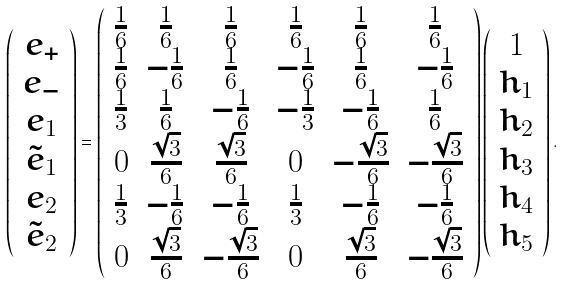Convert formula to latex. <formula><loc_0><loc_0><loc_500><loc_500>\left ( \begin{array} { c } e _ { + } \\ e _ { - } \\ e _ { 1 } \\ \tilde { e } _ { 1 } \\ e _ { 2 } \\ \tilde { e } _ { 2 } \\ \end{array} \right ) = \left ( \begin{array} { c c c c c c } \frac { 1 } { 6 } & \frac { 1 } { 6 } & \frac { 1 } { 6 } & \frac { 1 } { 6 } & \frac { 1 } { 6 } & \frac { 1 } { 6 } \\ \frac { 1 } { 6 } & - \frac { 1 } { 6 } & \frac { 1 } { 6 } & - \frac { 1 } { 6 } & \frac { 1 } { 6 } & - \frac { 1 } { 6 } \\ \frac { 1 } { 3 } & \frac { 1 } { 6 } & - \frac { 1 } { 6 } & - \frac { 1 } { 3 } & - \frac { 1 } { 6 } & \frac { 1 } { 6 } \\ 0 & \frac { \sqrt { 3 } } { 6 } & \frac { \sqrt { 3 } } { 6 } & 0 & - \frac { \sqrt { 3 } } { 6 } & - \frac { \sqrt { 3 } } { 6 } \\ \frac { 1 } { 3 } & - \frac { 1 } { 6 } & - \frac { 1 } { 6 } & \frac { 1 } { 3 } & - \frac { 1 } { 6 } & - \frac { 1 } { 6 } \\ 0 & \frac { \sqrt { 3 } } { 6 } & - \frac { \sqrt { 3 } } { 6 } & 0 & \frac { \sqrt { 3 } } { 6 } & - \frac { \sqrt { 3 } } { 6 } \\ \end{array} \right ) \left ( \begin{array} { c } 1 \\ h _ { 1 } \\ h _ { 2 } \\ h _ { 3 } \\ h _ { 4 } \\ h _ { 5 } \end{array} \right ) .</formula> 